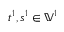Convert formula to latex. <formula><loc_0><loc_0><loc_500><loc_500>t ^ { 1 } , s ^ { 1 } \in \mathbb { V } ^ { 1 }</formula> 